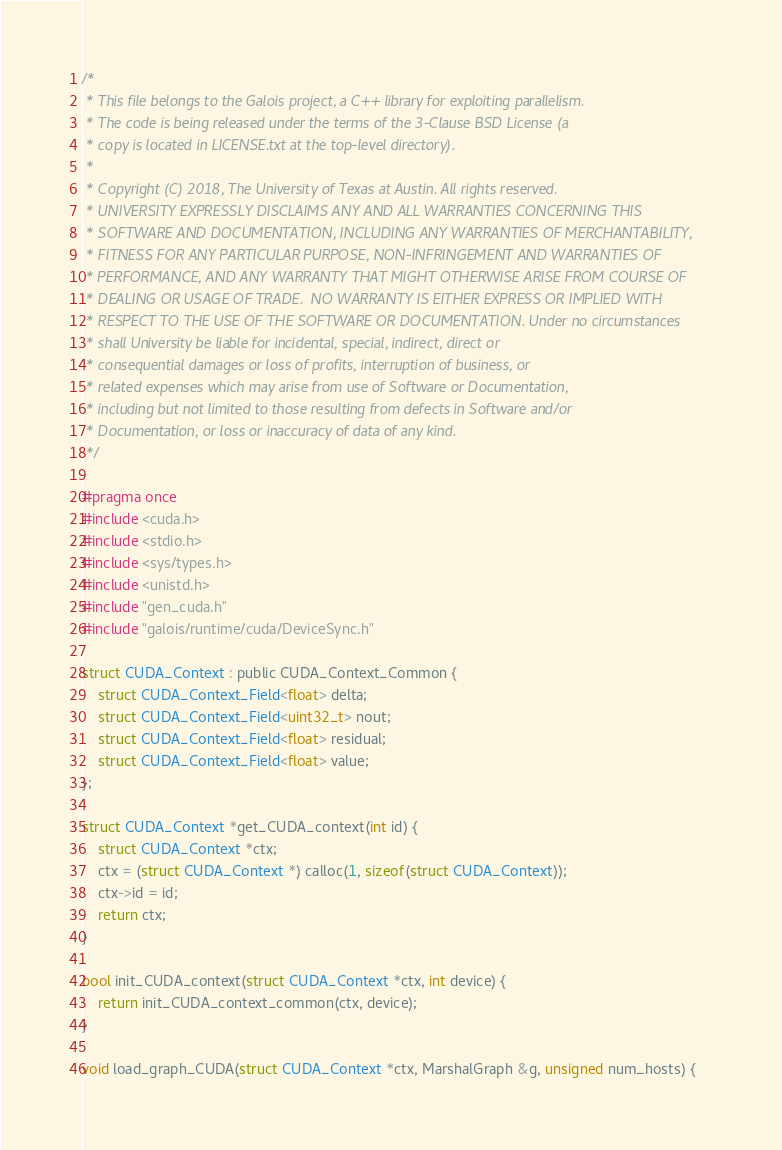Convert code to text. <code><loc_0><loc_0><loc_500><loc_500><_Cuda_>/*
 * This file belongs to the Galois project, a C++ library for exploiting parallelism.
 * The code is being released under the terms of the 3-Clause BSD License (a
 * copy is located in LICENSE.txt at the top-level directory).
 *
 * Copyright (C) 2018, The University of Texas at Austin. All rights reserved.
 * UNIVERSITY EXPRESSLY DISCLAIMS ANY AND ALL WARRANTIES CONCERNING THIS
 * SOFTWARE AND DOCUMENTATION, INCLUDING ANY WARRANTIES OF MERCHANTABILITY,
 * FITNESS FOR ANY PARTICULAR PURPOSE, NON-INFRINGEMENT AND WARRANTIES OF
 * PERFORMANCE, AND ANY WARRANTY THAT MIGHT OTHERWISE ARISE FROM COURSE OF
 * DEALING OR USAGE OF TRADE.  NO WARRANTY IS EITHER EXPRESS OR IMPLIED WITH
 * RESPECT TO THE USE OF THE SOFTWARE OR DOCUMENTATION. Under no circumstances
 * shall University be liable for incidental, special, indirect, direct or
 * consequential damages or loss of profits, interruption of business, or
 * related expenses which may arise from use of Software or Documentation,
 * including but not limited to those resulting from defects in Software and/or
 * Documentation, or loss or inaccuracy of data of any kind.
 */

#pragma once
#include <cuda.h>
#include <stdio.h>
#include <sys/types.h>
#include <unistd.h>
#include "gen_cuda.h"
#include "galois/runtime/cuda/DeviceSync.h"

struct CUDA_Context : public CUDA_Context_Common {
	struct CUDA_Context_Field<float> delta;
	struct CUDA_Context_Field<uint32_t> nout;
	struct CUDA_Context_Field<float> residual;
	struct CUDA_Context_Field<float> value;
};

struct CUDA_Context *get_CUDA_context(int id) {
	struct CUDA_Context *ctx;
	ctx = (struct CUDA_Context *) calloc(1, sizeof(struct CUDA_Context));
	ctx->id = id;
	return ctx;
}

bool init_CUDA_context(struct CUDA_Context *ctx, int device) {
	return init_CUDA_context_common(ctx, device);
}

void load_graph_CUDA(struct CUDA_Context *ctx, MarshalGraph &g, unsigned num_hosts) {</code> 